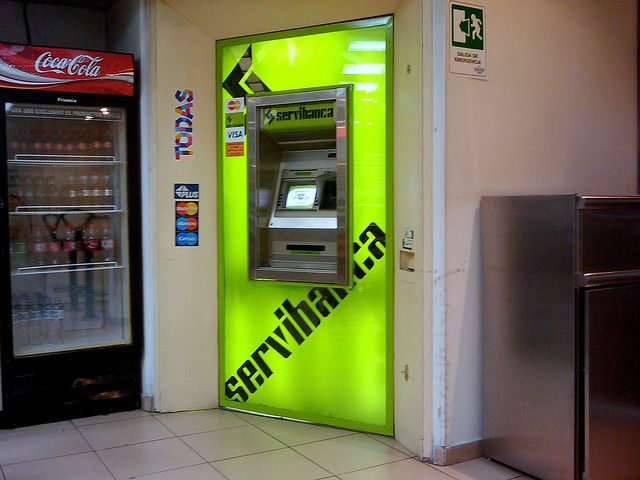Describe the objects in this image and their specific colors. I can see refrigerator in black, gray, and maroon tones, refrigerator in black, gray, and maroon tones, bottle in black, gray, and maroon tones, tv in black, gray, and lightblue tones, and bottle in black, gray, and darkblue tones in this image. 